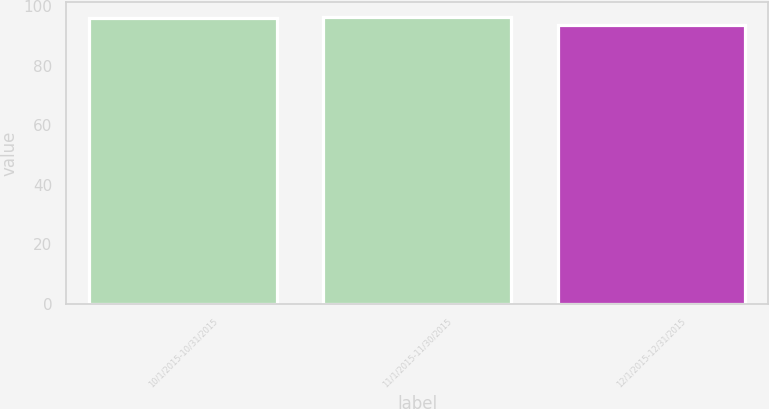<chart> <loc_0><loc_0><loc_500><loc_500><bar_chart><fcel>10/1/2015-10/31/2015<fcel>11/1/2015-11/30/2015<fcel>12/1/2015-12/31/2015<nl><fcel>96.24<fcel>96.51<fcel>93.78<nl></chart> 